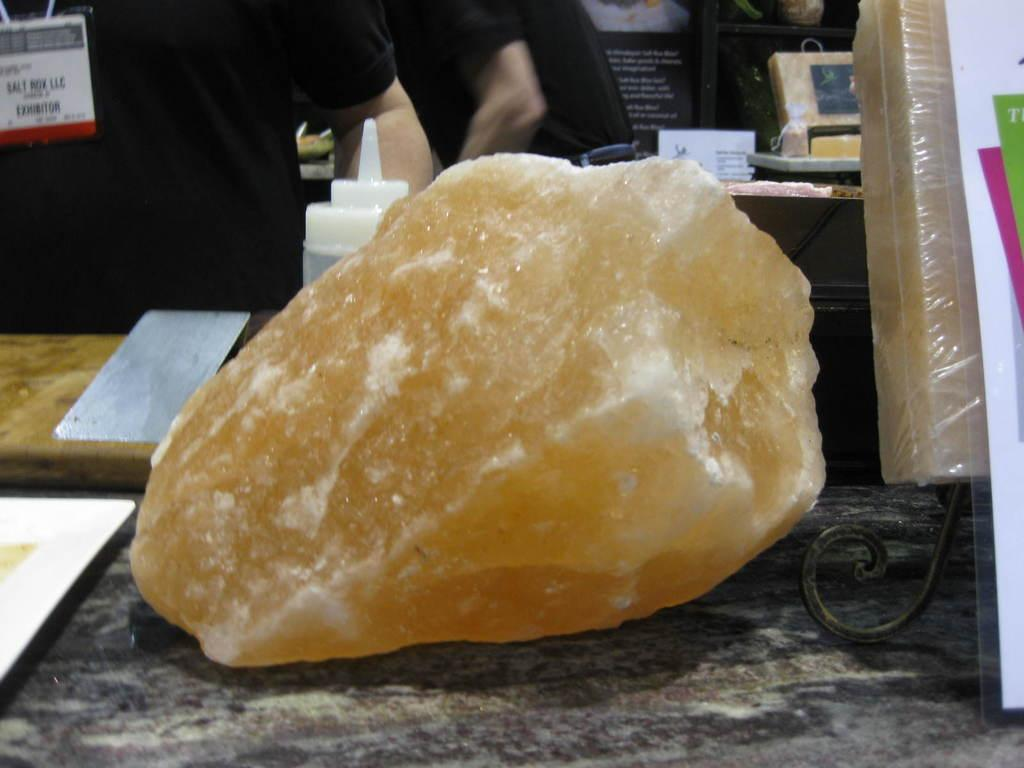What is the main object visible in the image? There is a bottle in the image. What is the location of the bottle in the image? The bottle is on a table. Can you describe the background of the image? There are people and objects on the table in the background. How many dolls are sitting on the bottle in the image? There are no dolls present in the image, and the bottle does not have any dolls sitting on it. 